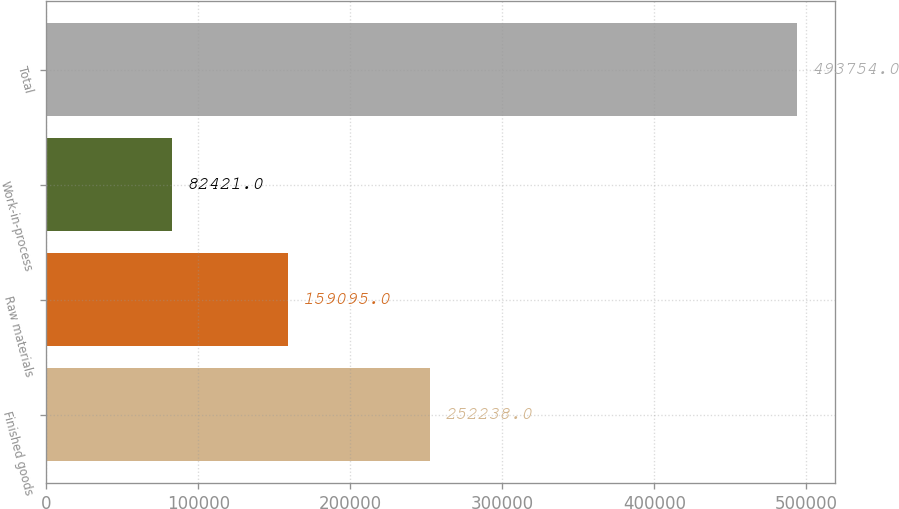<chart> <loc_0><loc_0><loc_500><loc_500><bar_chart><fcel>Finished goods<fcel>Raw materials<fcel>Work-in-process<fcel>Total<nl><fcel>252238<fcel>159095<fcel>82421<fcel>493754<nl></chart> 